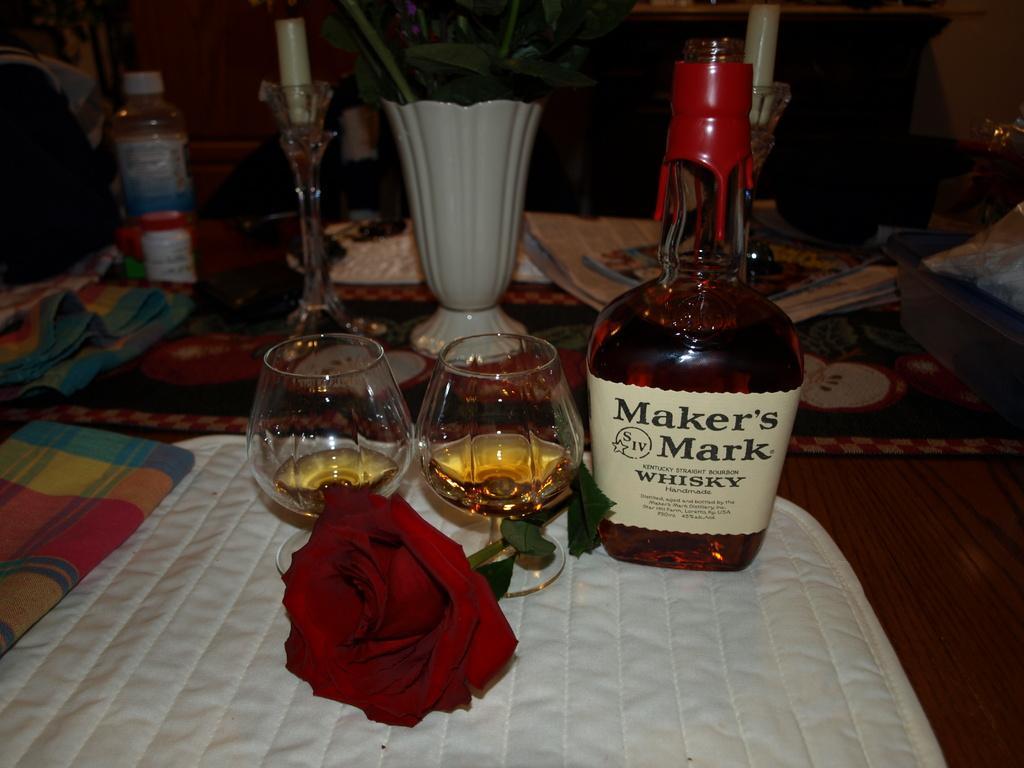How would you summarize this image in a sentence or two? In the image we can see there is a table on which there are wine glasses, wine bottle and a rose plant flower. 